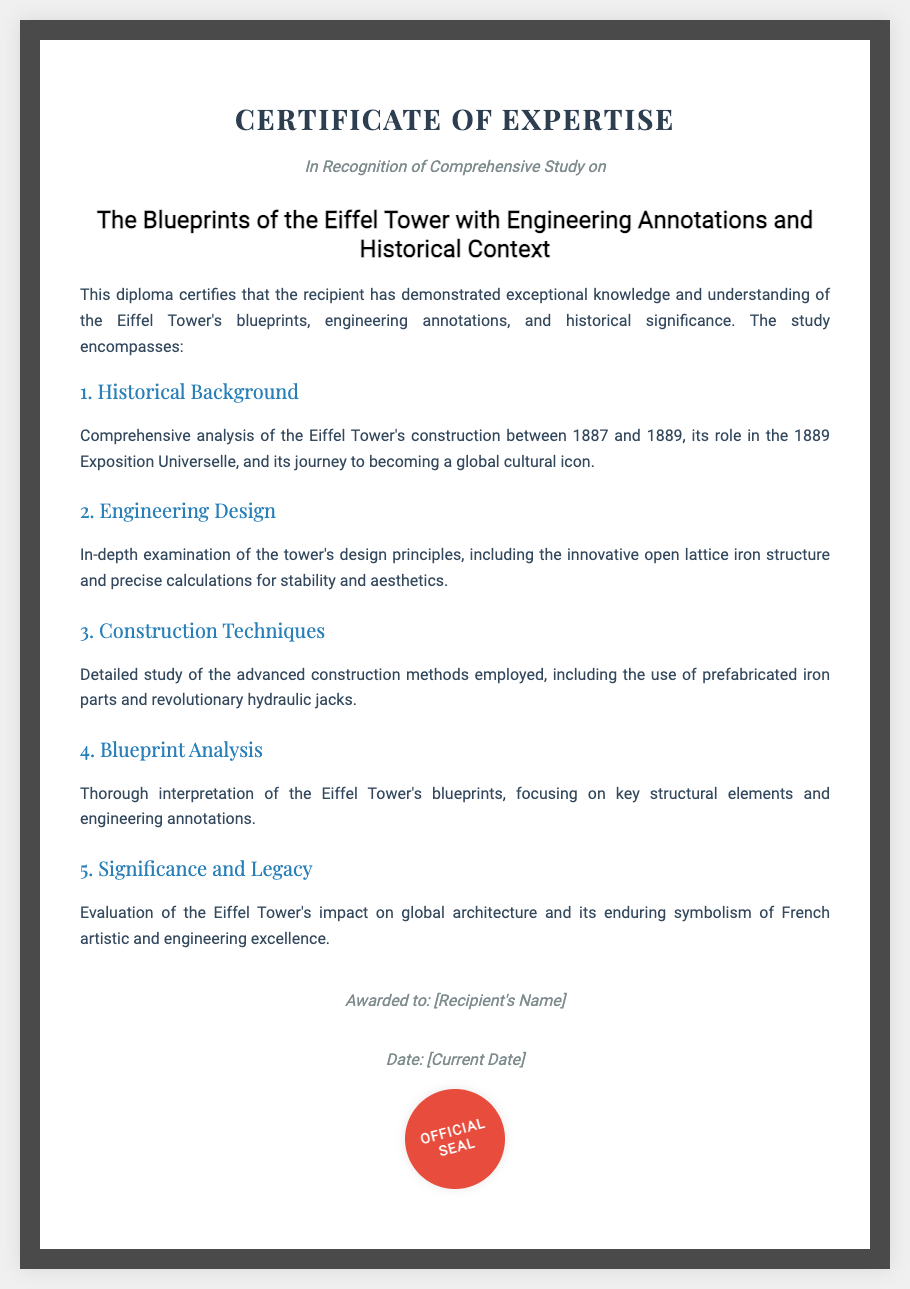What is the title of the diploma? The title is explicitly stated in the document as the main focus of the study.
Answer: The Blueprints of the Eiffel Tower with Engineering Annotations and Historical Context What year was the Eiffel Tower constructed? The diploma specifies the years of construction in the historical background section.
Answer: 1887 to 1889 What event did the Eiffel Tower play a role in? This information is found in the historical background section, discussing its significance related to an event.
Answer: 1889 Exposition Universelle What design principle is highlighted in the engineering design section? The document mentions specific characteristics of the structure within the engineering design section.
Answer: Open lattice iron structure What innovative construction method was employed? The detailed study of construction techniques mentions specific methods used during construction.
Answer: Prefabricated iron parts What is one significant impact of the Eiffel Tower discussed? The significance and legacy section evaluates the Eiffel Tower's influence on global architecture.
Answer: Global architecture How many sections are there in the content? By counting the numbered sections listed in the content, we find the total.
Answer: Five Who is the diploma awarded to? The document has a placeholder indicating the recipient's name.
Answer: [Recipient's Name] What color is the official seal? The visual description of the seal in the document specifies its color.
Answer: Red 